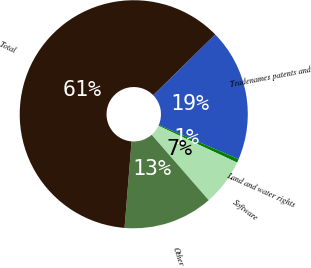Convert chart. <chart><loc_0><loc_0><loc_500><loc_500><pie_chart><fcel>Tradenames patents and<fcel>Land and water rights<fcel>Software<fcel>Other<fcel>Total<nl><fcel>18.78%<fcel>0.53%<fcel>6.62%<fcel>12.7%<fcel>61.37%<nl></chart> 